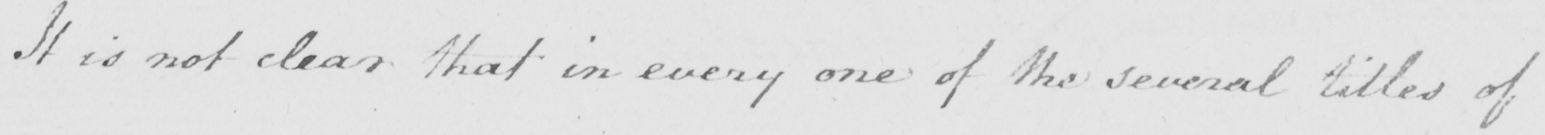What is written in this line of handwriting? It is not clear that in every one of the several titles of 